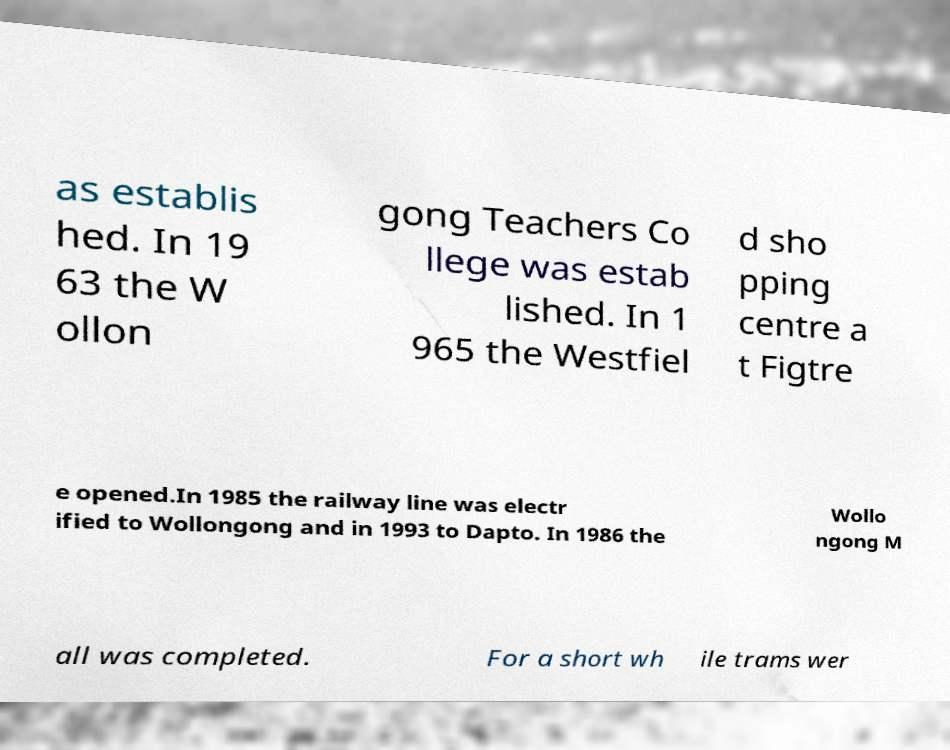Please read and relay the text visible in this image. What does it say? as establis hed. In 19 63 the W ollon gong Teachers Co llege was estab lished. In 1 965 the Westfiel d sho pping centre a t Figtre e opened.In 1985 the railway line was electr ified to Wollongong and in 1993 to Dapto. In 1986 the Wollo ngong M all was completed. For a short wh ile trams wer 